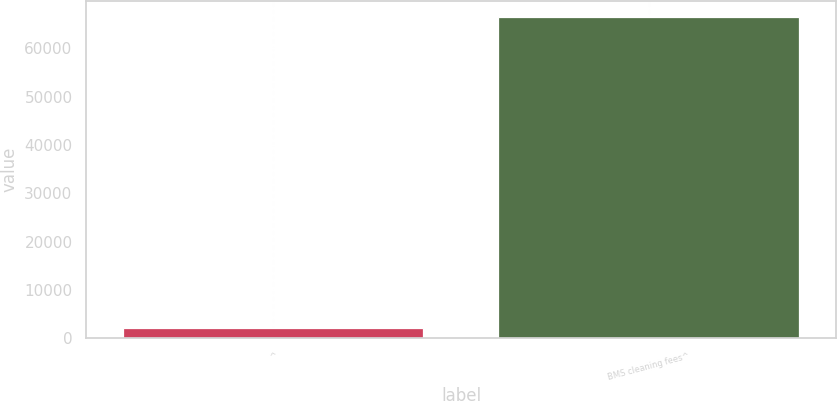<chart> <loc_0><loc_0><loc_500><loc_500><bar_chart><fcel>^<fcel>BMS cleaning fees^<nl><fcel>2013<fcel>66505<nl></chart> 